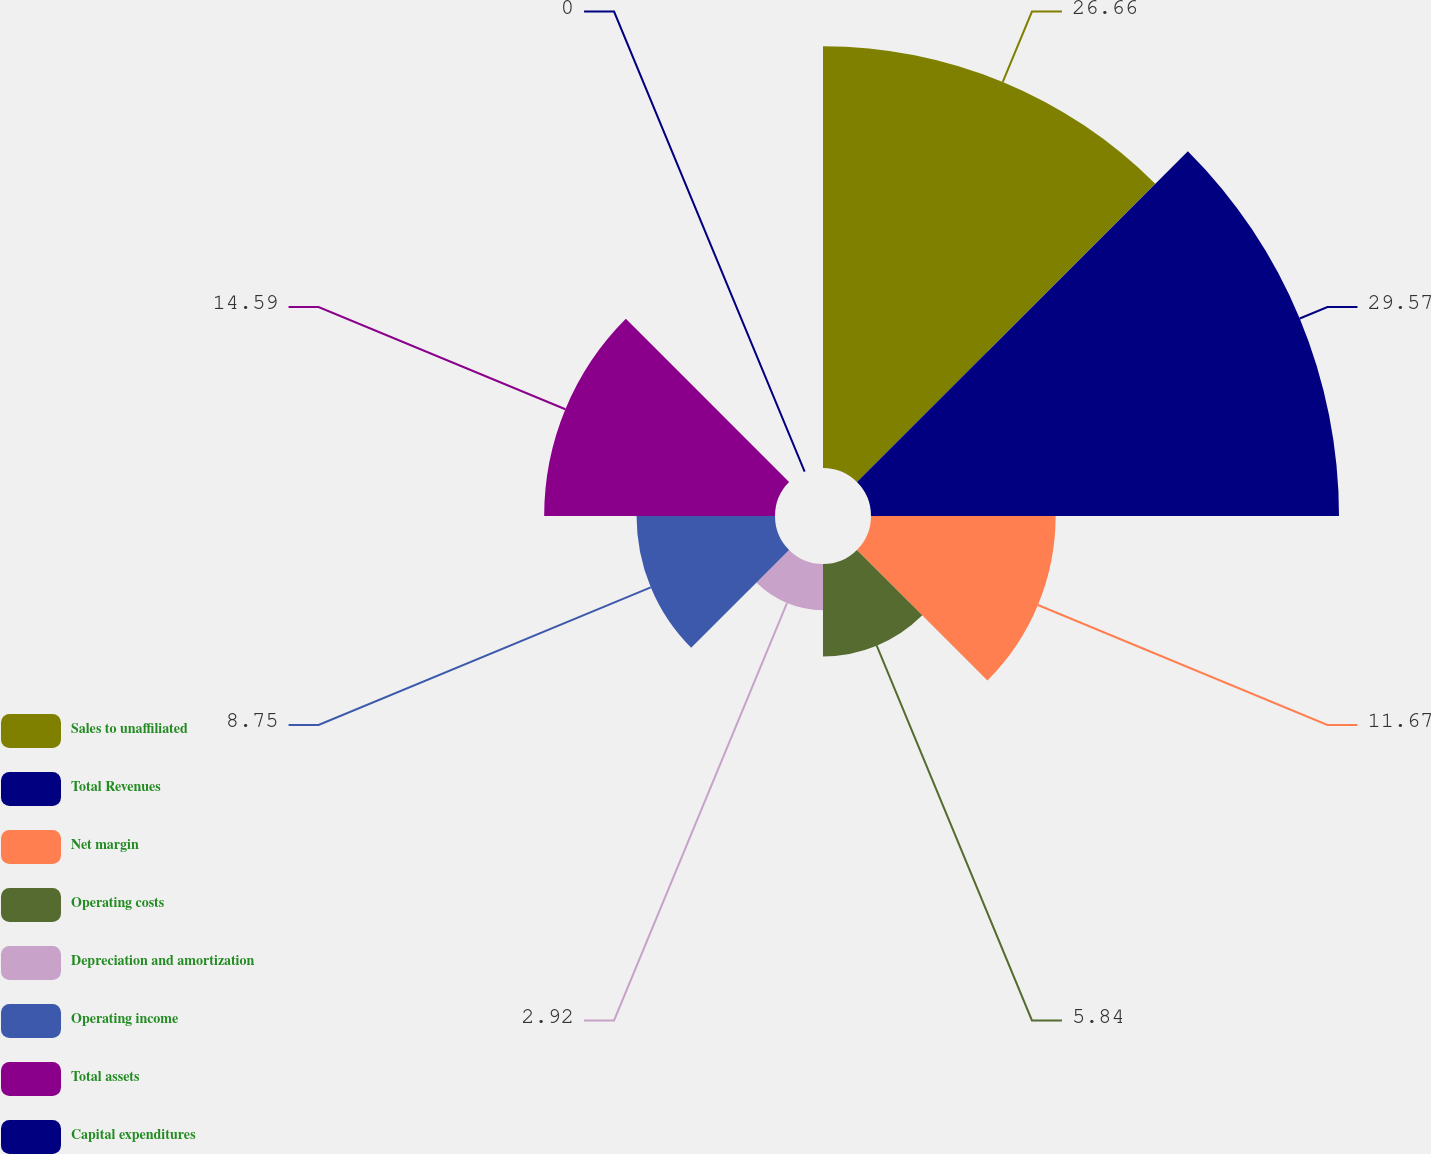Convert chart. <chart><loc_0><loc_0><loc_500><loc_500><pie_chart><fcel>Sales to unaffiliated<fcel>Total Revenues<fcel>Net margin<fcel>Operating costs<fcel>Depreciation and amortization<fcel>Operating income<fcel>Total assets<fcel>Capital expenditures<nl><fcel>26.66%<fcel>29.58%<fcel>11.67%<fcel>5.84%<fcel>2.92%<fcel>8.75%<fcel>14.59%<fcel>0.0%<nl></chart> 